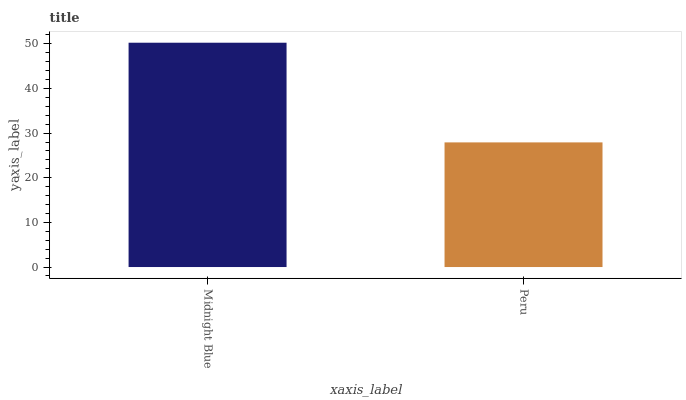Is Peru the maximum?
Answer yes or no. No. Is Midnight Blue greater than Peru?
Answer yes or no. Yes. Is Peru less than Midnight Blue?
Answer yes or no. Yes. Is Peru greater than Midnight Blue?
Answer yes or no. No. Is Midnight Blue less than Peru?
Answer yes or no. No. Is Midnight Blue the high median?
Answer yes or no. Yes. Is Peru the low median?
Answer yes or no. Yes. Is Peru the high median?
Answer yes or no. No. Is Midnight Blue the low median?
Answer yes or no. No. 